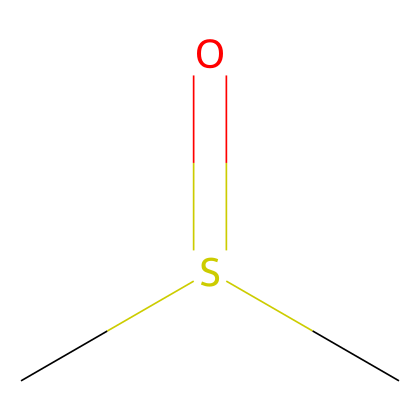What is the molecular formula of dimethyl sulfoxide? The molecular formula is derived from the count of each type of atom present in the compound as represented in the SMILES. In the SMILES, there are two carbon atoms (C), one sulfur atom (S), and one oxygen atom (O) indicated, leading to the formula C2H6OS.
Answer: C2H6OS How many carbon atoms are in dimethyl sulfoxide? From the SMILES, there are two 'C' symbols which represent carbon atoms. Therefore, the number of carbon atoms can be counted directly.
Answer: 2 What type of solvent is dimethyl sulfoxide? Dimethyl sulfoxide is identified as a polar aprotic solvent due to its structure, which contains a sulfur atom bonded to an oxygen, contributing to its high dielectric constant and ability to dissolve a wide range of compounds.
Answer: polar aprotic Describe the functional group present in dimethyl sulfoxide. The functional group in dimethyl sulfoxide is the sulfoxide group, represented by the sulfur atom bonded to an oxygen atom (S=O), which gives the compound its unique chemical properties.
Answer: sulfoxide What is the hybridization of the carbon atoms in dimethyl sulfoxide? The hybridization of the carbon atoms can be determined by examining their bonding. Each carbon in DMSO is connected to three other atoms, indicating that they are sp3 hybridized as they form four bonds in a tetrahedral arrangement.
Answer: sp3 Which atom in dimethyl sulfoxide has a formal positive charge in some conditions? In dimethyl sulfoxide, the sulfur atom can exhibit formal positive charge characteristics depending on its bonding environment and interactions with other molecules, contributing to its electrophilic behavior.
Answer: sulfur 